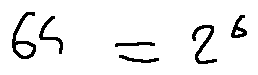Convert formula to latex. <formula><loc_0><loc_0><loc_500><loc_500>6 4 = 2 ^ { 6 }</formula> 